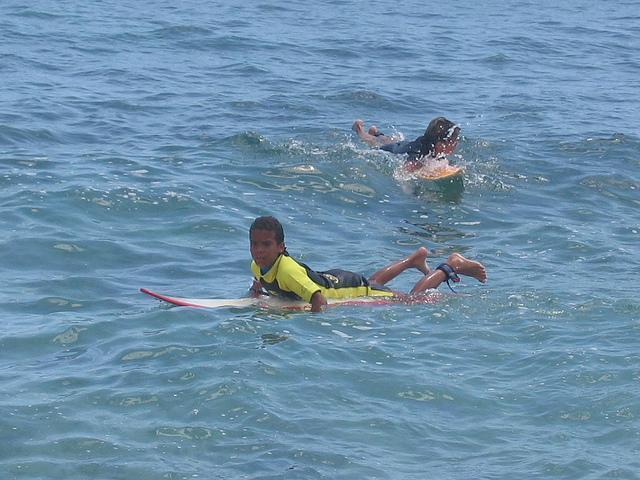How many people are in the photo?
Give a very brief answer. 2. How many people are there?
Give a very brief answer. 2. How many airplanes are there flying in the photo?
Give a very brief answer. 0. 